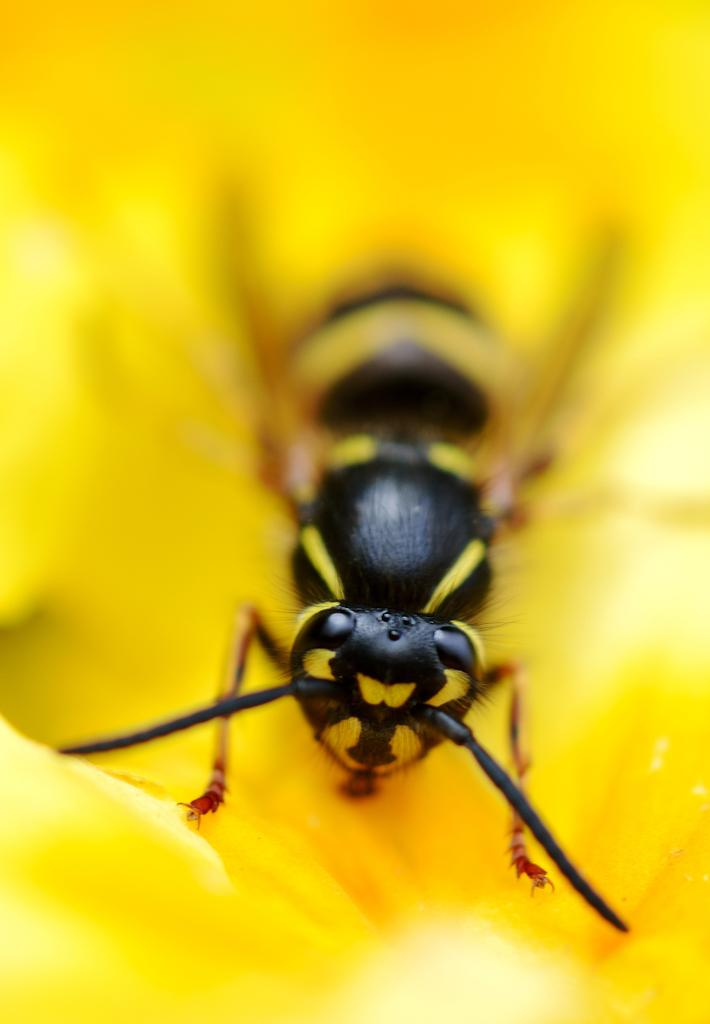What type of creature is in the picture? There is an insect in the picture. Can you describe the coloring of the insect? The insect has black and yellow coloring. What color is the background of the image? The background of the image is completely yellow. How many babies are visible in the image? There are no babies present in the image; it features an insect with black and yellow coloring against a yellow background. 